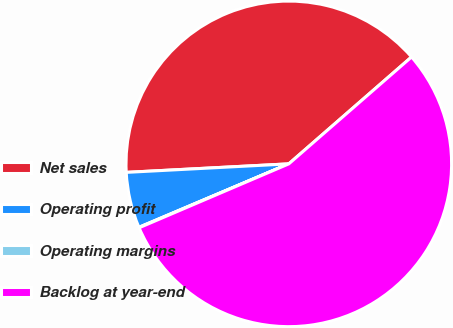Convert chart. <chart><loc_0><loc_0><loc_500><loc_500><pie_chart><fcel>Net sales<fcel>Operating profit<fcel>Operating margins<fcel>Backlog at year-end<nl><fcel>39.43%<fcel>5.54%<fcel>0.05%<fcel>54.98%<nl></chart> 